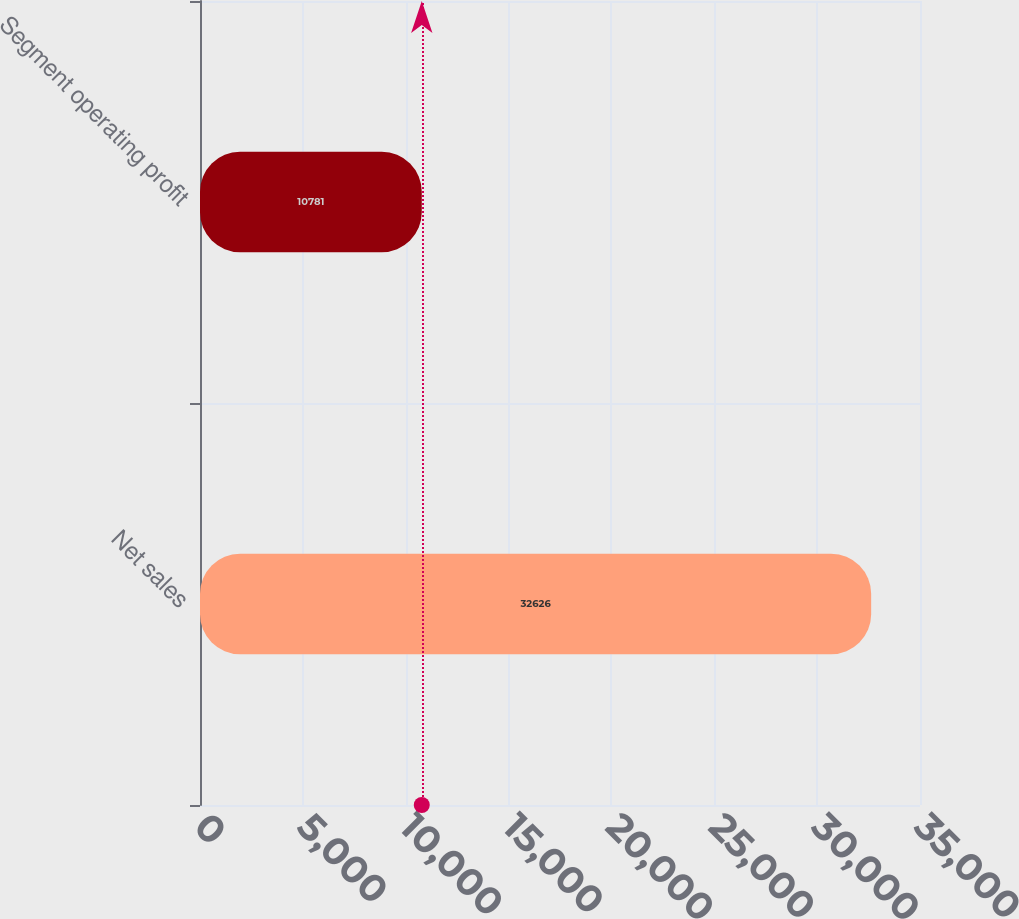<chart> <loc_0><loc_0><loc_500><loc_500><bar_chart><fcel>Net sales<fcel>Segment operating profit<nl><fcel>32626<fcel>10781<nl></chart> 